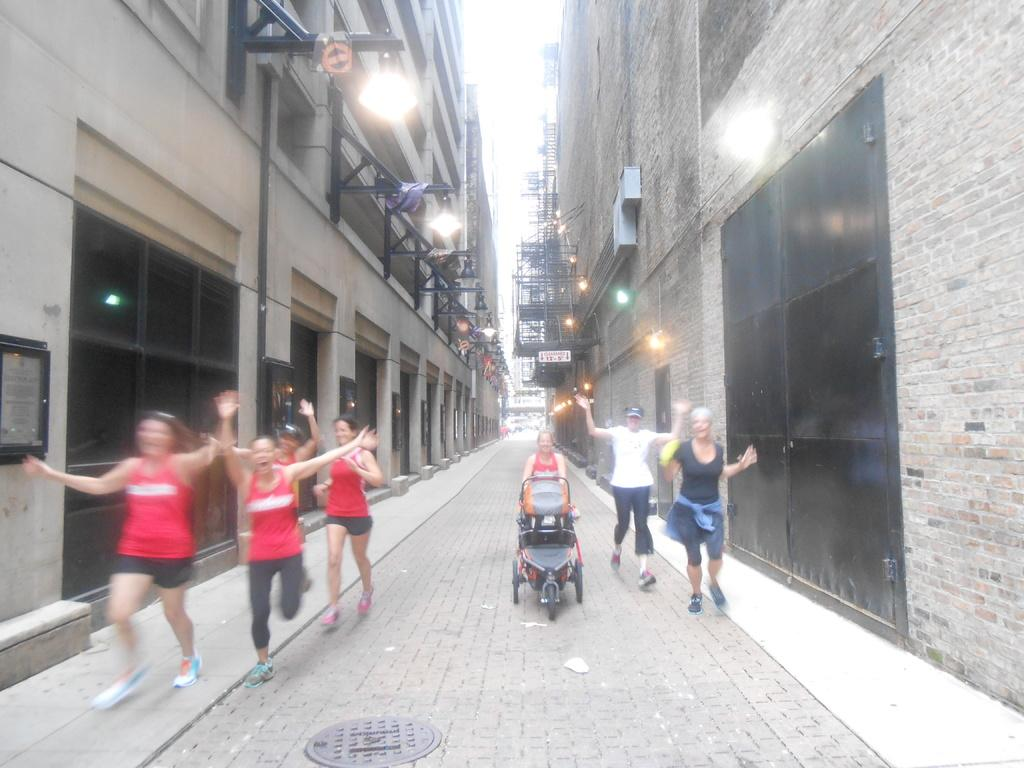What is the main object in the image? There is a manhole in the image. What else can be seen on the ground in the image? There are people on the ground in the image. What type of transportation device is present in the image? There is a stroller in the image. What type of structures are visible in the image? There are buildings in the image. What type of illumination is present in the image? There are lights in the image. What other objects can be seen in the image? There are some objects in the image. What type of credit card is being used by the people in the image? There is no credit card visible in the image; it only shows a manhole, people, a stroller, buildings, lights, and other objects. 